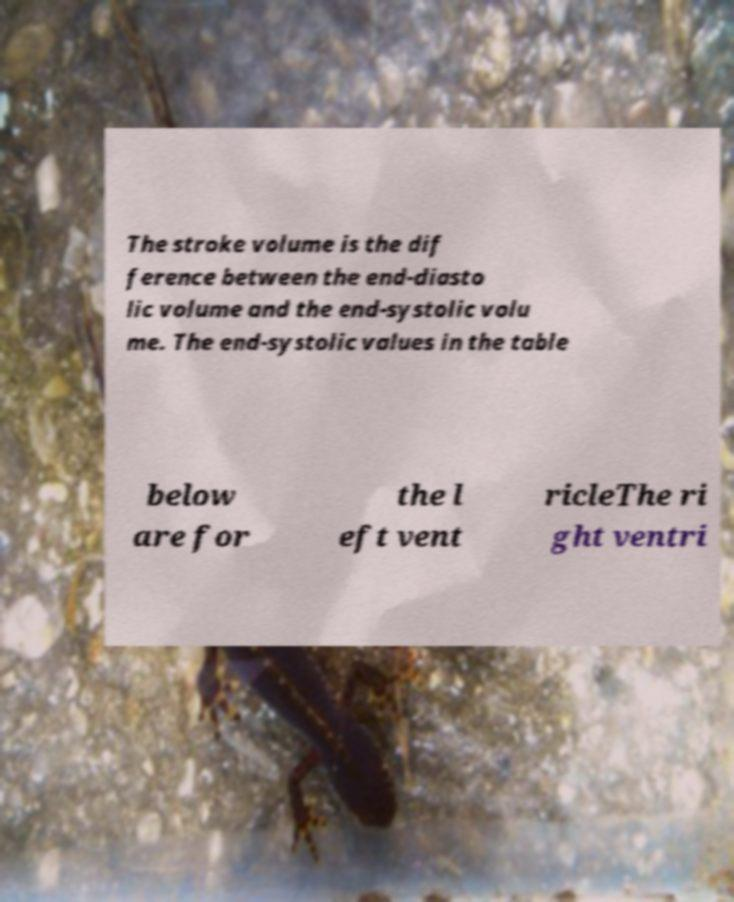Can you accurately transcribe the text from the provided image for me? The stroke volume is the dif ference between the end-diasto lic volume and the end-systolic volu me. The end-systolic values in the table below are for the l eft vent ricleThe ri ght ventri 